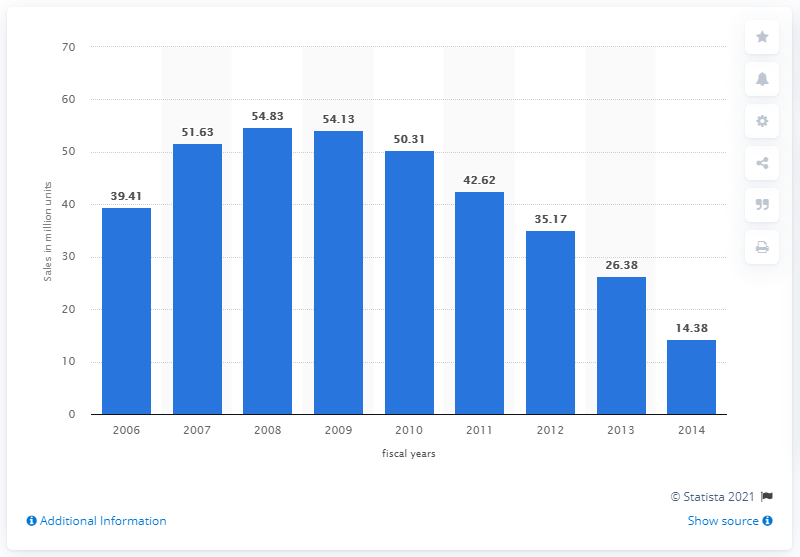Outline some significant characteristics in this image. In 2008, it is estimated that a total of 54.83 million iPods were sold worldwide. 